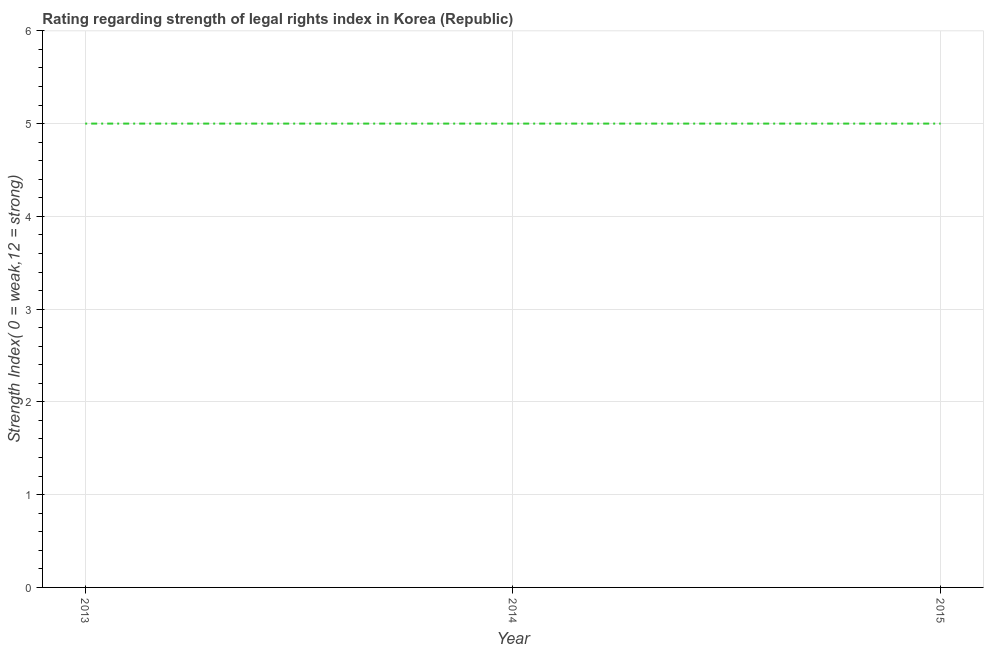What is the strength of legal rights index in 2013?
Provide a succinct answer. 5. Across all years, what is the maximum strength of legal rights index?
Offer a terse response. 5. Across all years, what is the minimum strength of legal rights index?
Provide a short and direct response. 5. In which year was the strength of legal rights index minimum?
Your answer should be compact. 2013. What is the sum of the strength of legal rights index?
Make the answer very short. 15. What is the difference between the strength of legal rights index in 2013 and 2014?
Ensure brevity in your answer.  0. What is the average strength of legal rights index per year?
Ensure brevity in your answer.  5. In how many years, is the strength of legal rights index greater than 1.6 ?
Your answer should be compact. 3. Is the difference between the strength of legal rights index in 2014 and 2015 greater than the difference between any two years?
Offer a very short reply. Yes. Is the sum of the strength of legal rights index in 2014 and 2015 greater than the maximum strength of legal rights index across all years?
Give a very brief answer. Yes. What is the difference between the highest and the lowest strength of legal rights index?
Your answer should be very brief. 0. In how many years, is the strength of legal rights index greater than the average strength of legal rights index taken over all years?
Your response must be concise. 0. Are the values on the major ticks of Y-axis written in scientific E-notation?
Ensure brevity in your answer.  No. Does the graph contain any zero values?
Your answer should be compact. No. What is the title of the graph?
Your answer should be very brief. Rating regarding strength of legal rights index in Korea (Republic). What is the label or title of the Y-axis?
Provide a succinct answer. Strength Index( 0 = weak,12 = strong). What is the difference between the Strength Index( 0 = weak,12 = strong) in 2013 and 2014?
Keep it short and to the point. 0. What is the difference between the Strength Index( 0 = weak,12 = strong) in 2013 and 2015?
Provide a succinct answer. 0. What is the ratio of the Strength Index( 0 = weak,12 = strong) in 2013 to that in 2014?
Offer a very short reply. 1. 